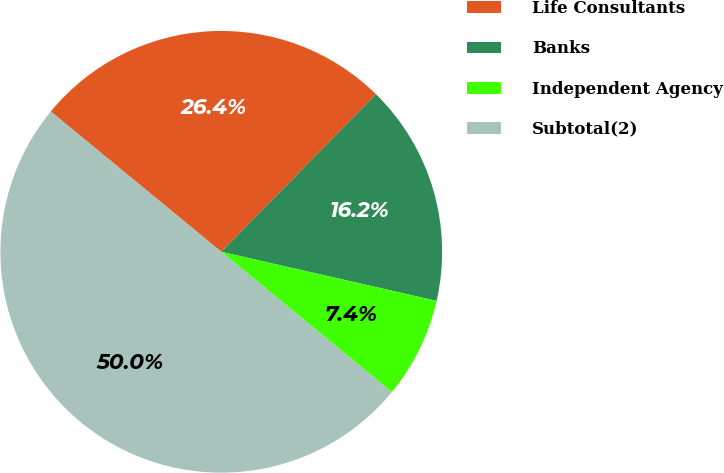Convert chart. <chart><loc_0><loc_0><loc_500><loc_500><pie_chart><fcel>Life Consultants<fcel>Banks<fcel>Independent Agency<fcel>Subtotal(2)<nl><fcel>26.4%<fcel>16.21%<fcel>7.39%<fcel>50.0%<nl></chart> 